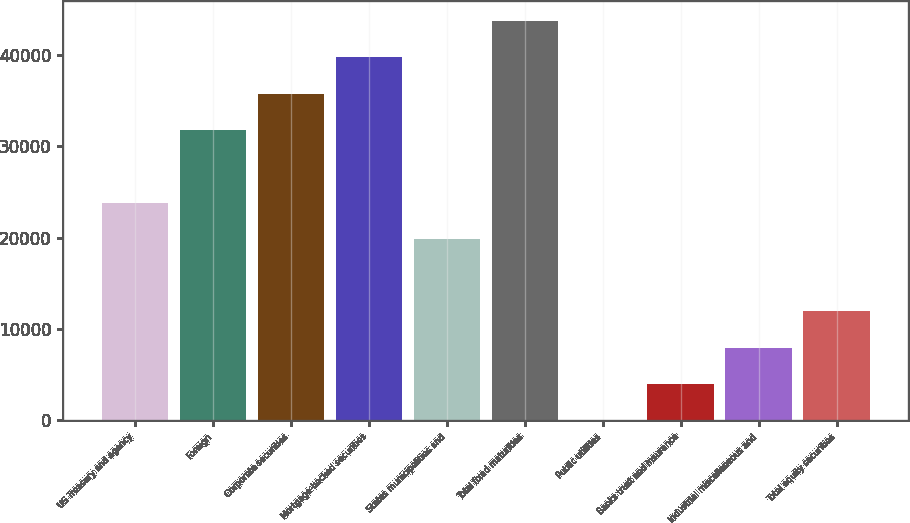<chart> <loc_0><loc_0><loc_500><loc_500><bar_chart><fcel>US Treasury and agency<fcel>Foreign<fcel>Corporate securities<fcel>Mortgage-backed securities<fcel>States municipalities and<fcel>Total fixed maturities<fcel>Public utilities<fcel>Banks trust and insurance<fcel>Industrial miscellaneous and<fcel>Total equity securities<nl><fcel>23842.4<fcel>31781.2<fcel>35750.6<fcel>39720<fcel>19873<fcel>43689.4<fcel>26<fcel>3995.4<fcel>7964.8<fcel>11934.2<nl></chart> 